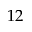Convert formula to latex. <formula><loc_0><loc_0><loc_500><loc_500>1 2</formula> 